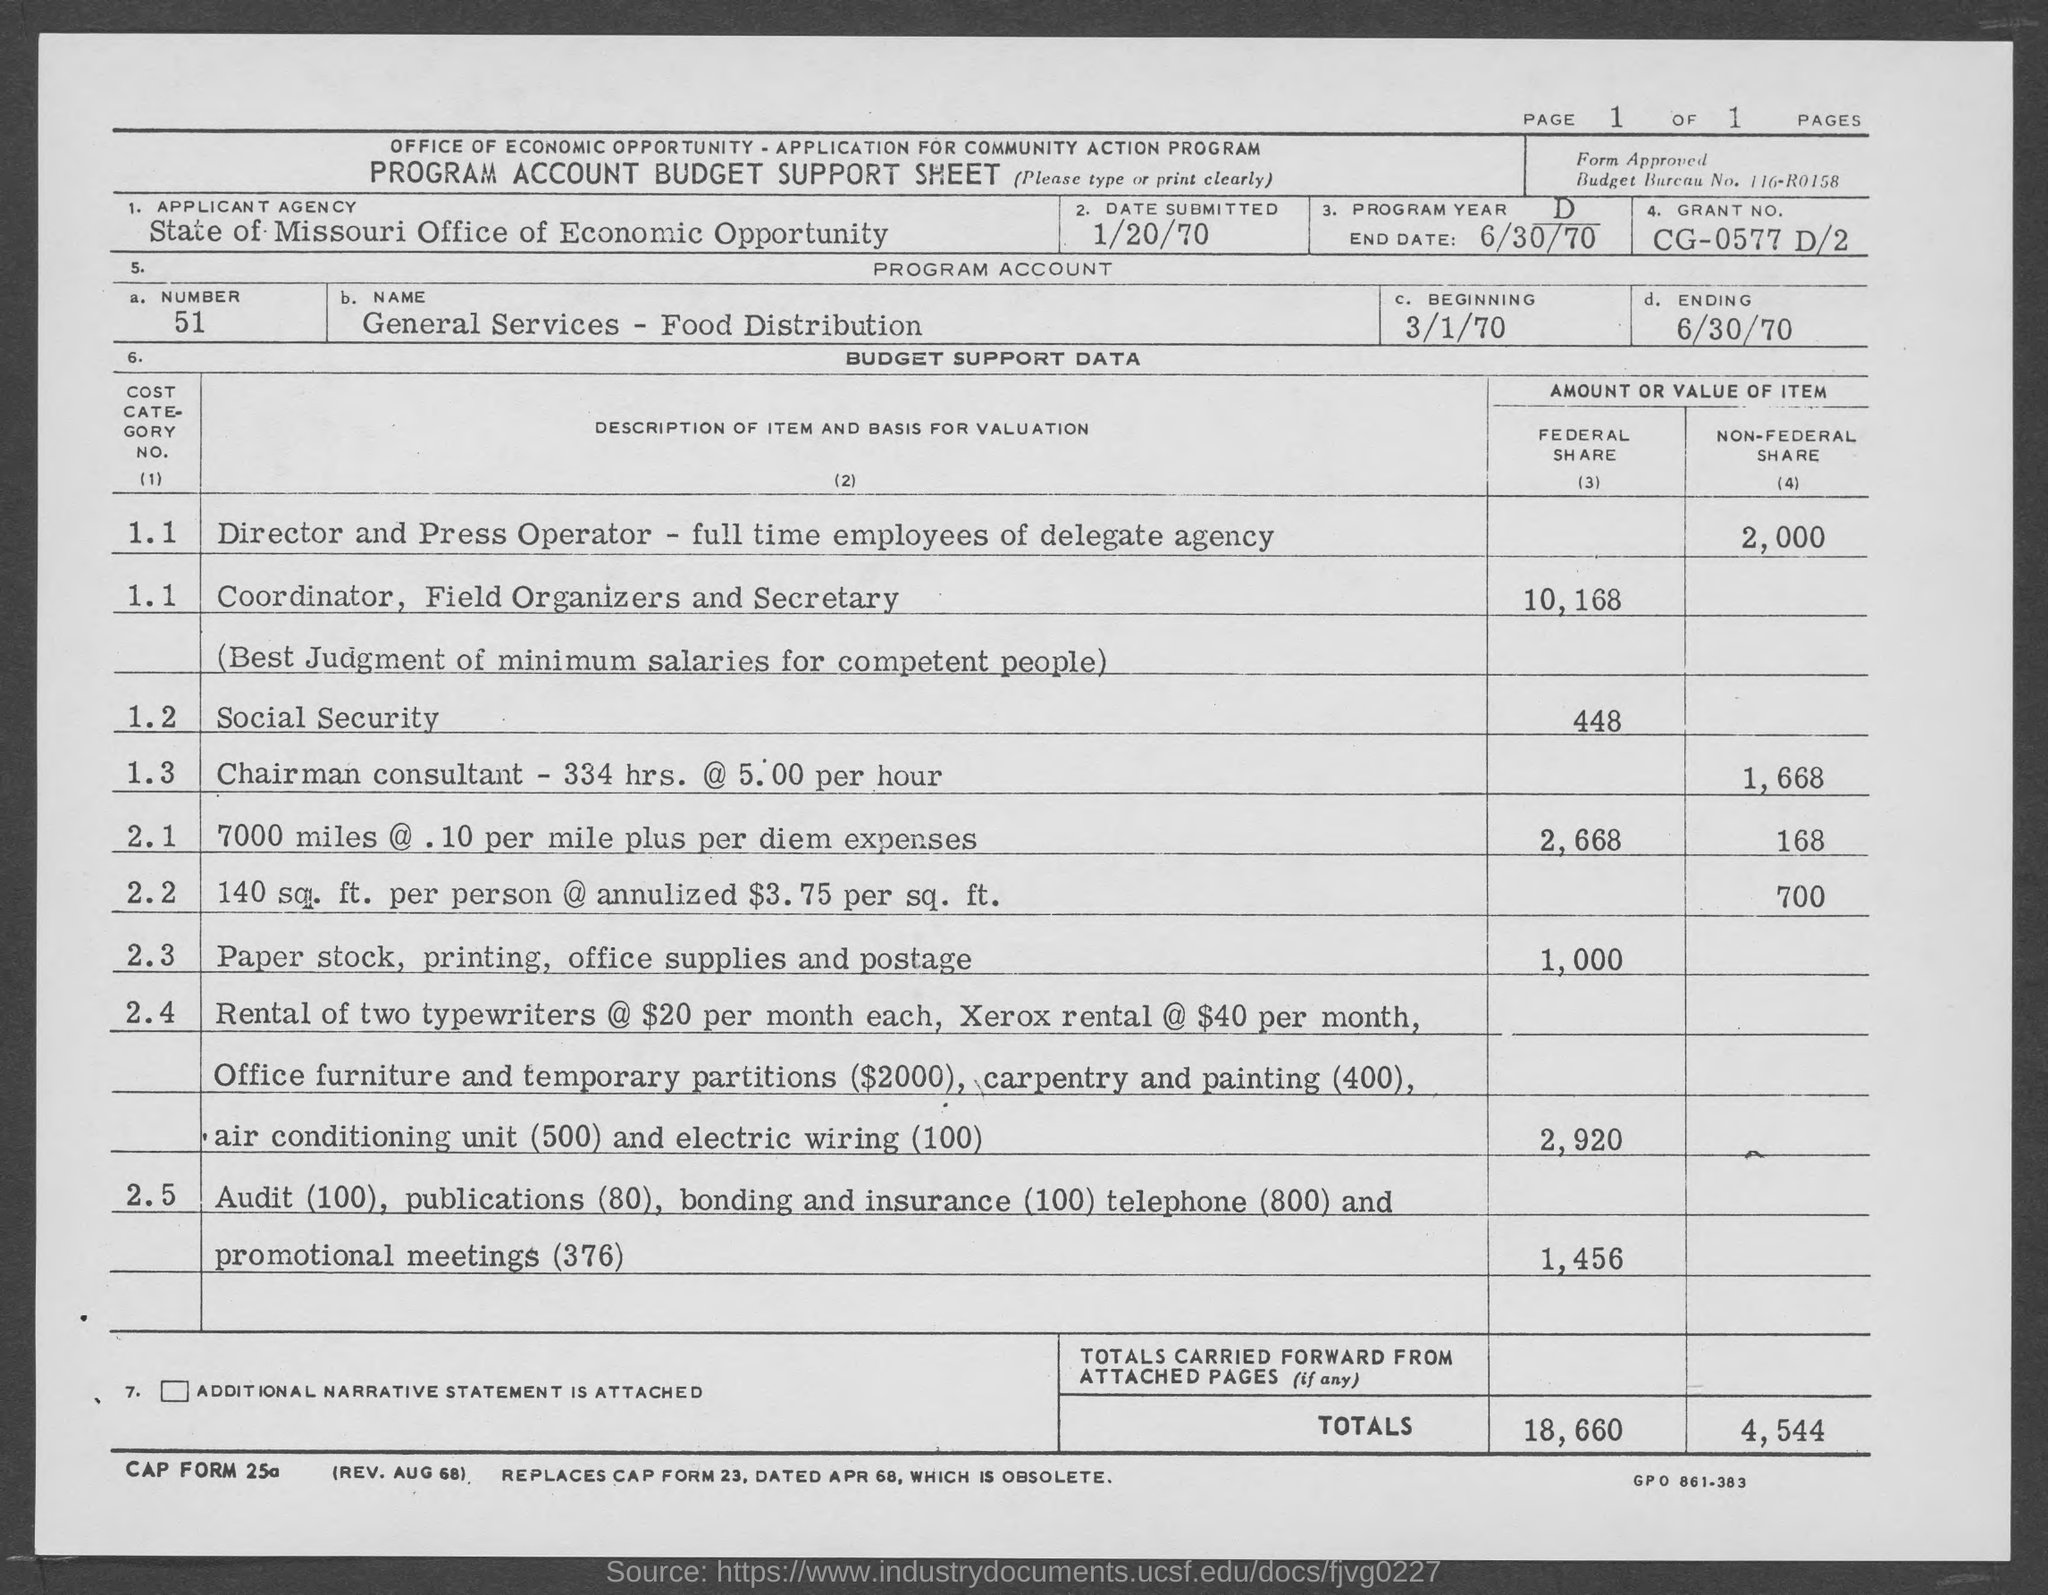Mention a couple of crucial points in this snapshot. What is the number? 51, as in the number following 50 and preceding 52. The name of the organization is General Services, and it is involved in food distribution. The Grant No. is CG-0577 D/2. The page number is 1, as declared. The end date is 6/30/70. 